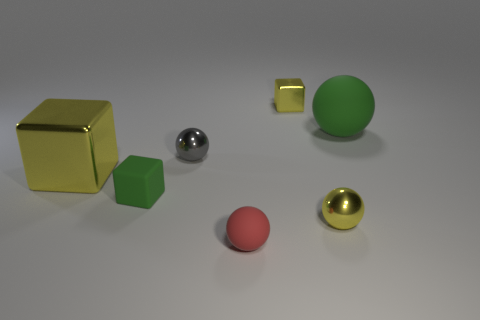Subtract all purple spheres. How many yellow cubes are left? 2 Add 3 yellow metallic blocks. How many objects exist? 10 Subtract all yellow blocks. How many blocks are left? 1 Subtract all gray balls. How many balls are left? 3 Subtract all balls. How many objects are left? 3 Subtract all purple balls. Subtract all green cylinders. How many balls are left? 4 Add 1 metallic balls. How many metallic balls are left? 3 Add 4 small red matte objects. How many small red matte objects exist? 5 Subtract 0 brown cylinders. How many objects are left? 7 Subtract all big cyan objects. Subtract all tiny gray metal objects. How many objects are left? 6 